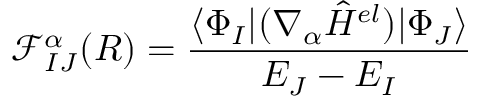<formula> <loc_0><loc_0><loc_500><loc_500>\mathcal { F } _ { I J } ^ { \alpha } ( R ) = \frac { \langle \Phi _ { I } | ( \nabla _ { \alpha } \hat { H } ^ { e l } ) | \Phi _ { J } \rangle } { E _ { J } - E _ { I } }</formula> 